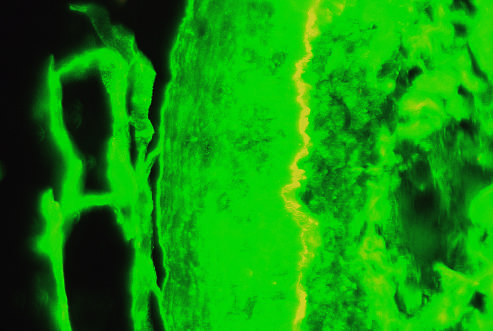what is on the left side of the fluorescent band?
Answer the question using a single word or phrase. Epidermis 